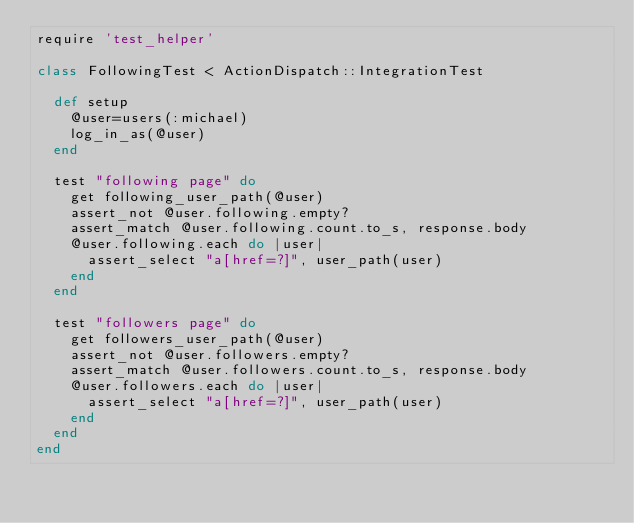Convert code to text. <code><loc_0><loc_0><loc_500><loc_500><_Ruby_>require 'test_helper'

class FollowingTest < ActionDispatch::IntegrationTest
  
  def setup
    @user=users(:michael)
    log_in_as(@user)
  end 
  
  test "following page" do
    get following_user_path(@user)
    assert_not @user.following.empty?
    assert_match @user.following.count.to_s, response.body
    @user.following.each do |user|
      assert_select "a[href=?]", user_path(user)
    end
  end
  
  test "followers page" do
    get followers_user_path(@user)
    assert_not @user.followers.empty?
    assert_match @user.followers.count.to_s, response.body
    @user.followers.each do |user|
      assert_select "a[href=?]", user_path(user)
    end
  end 
end
</code> 